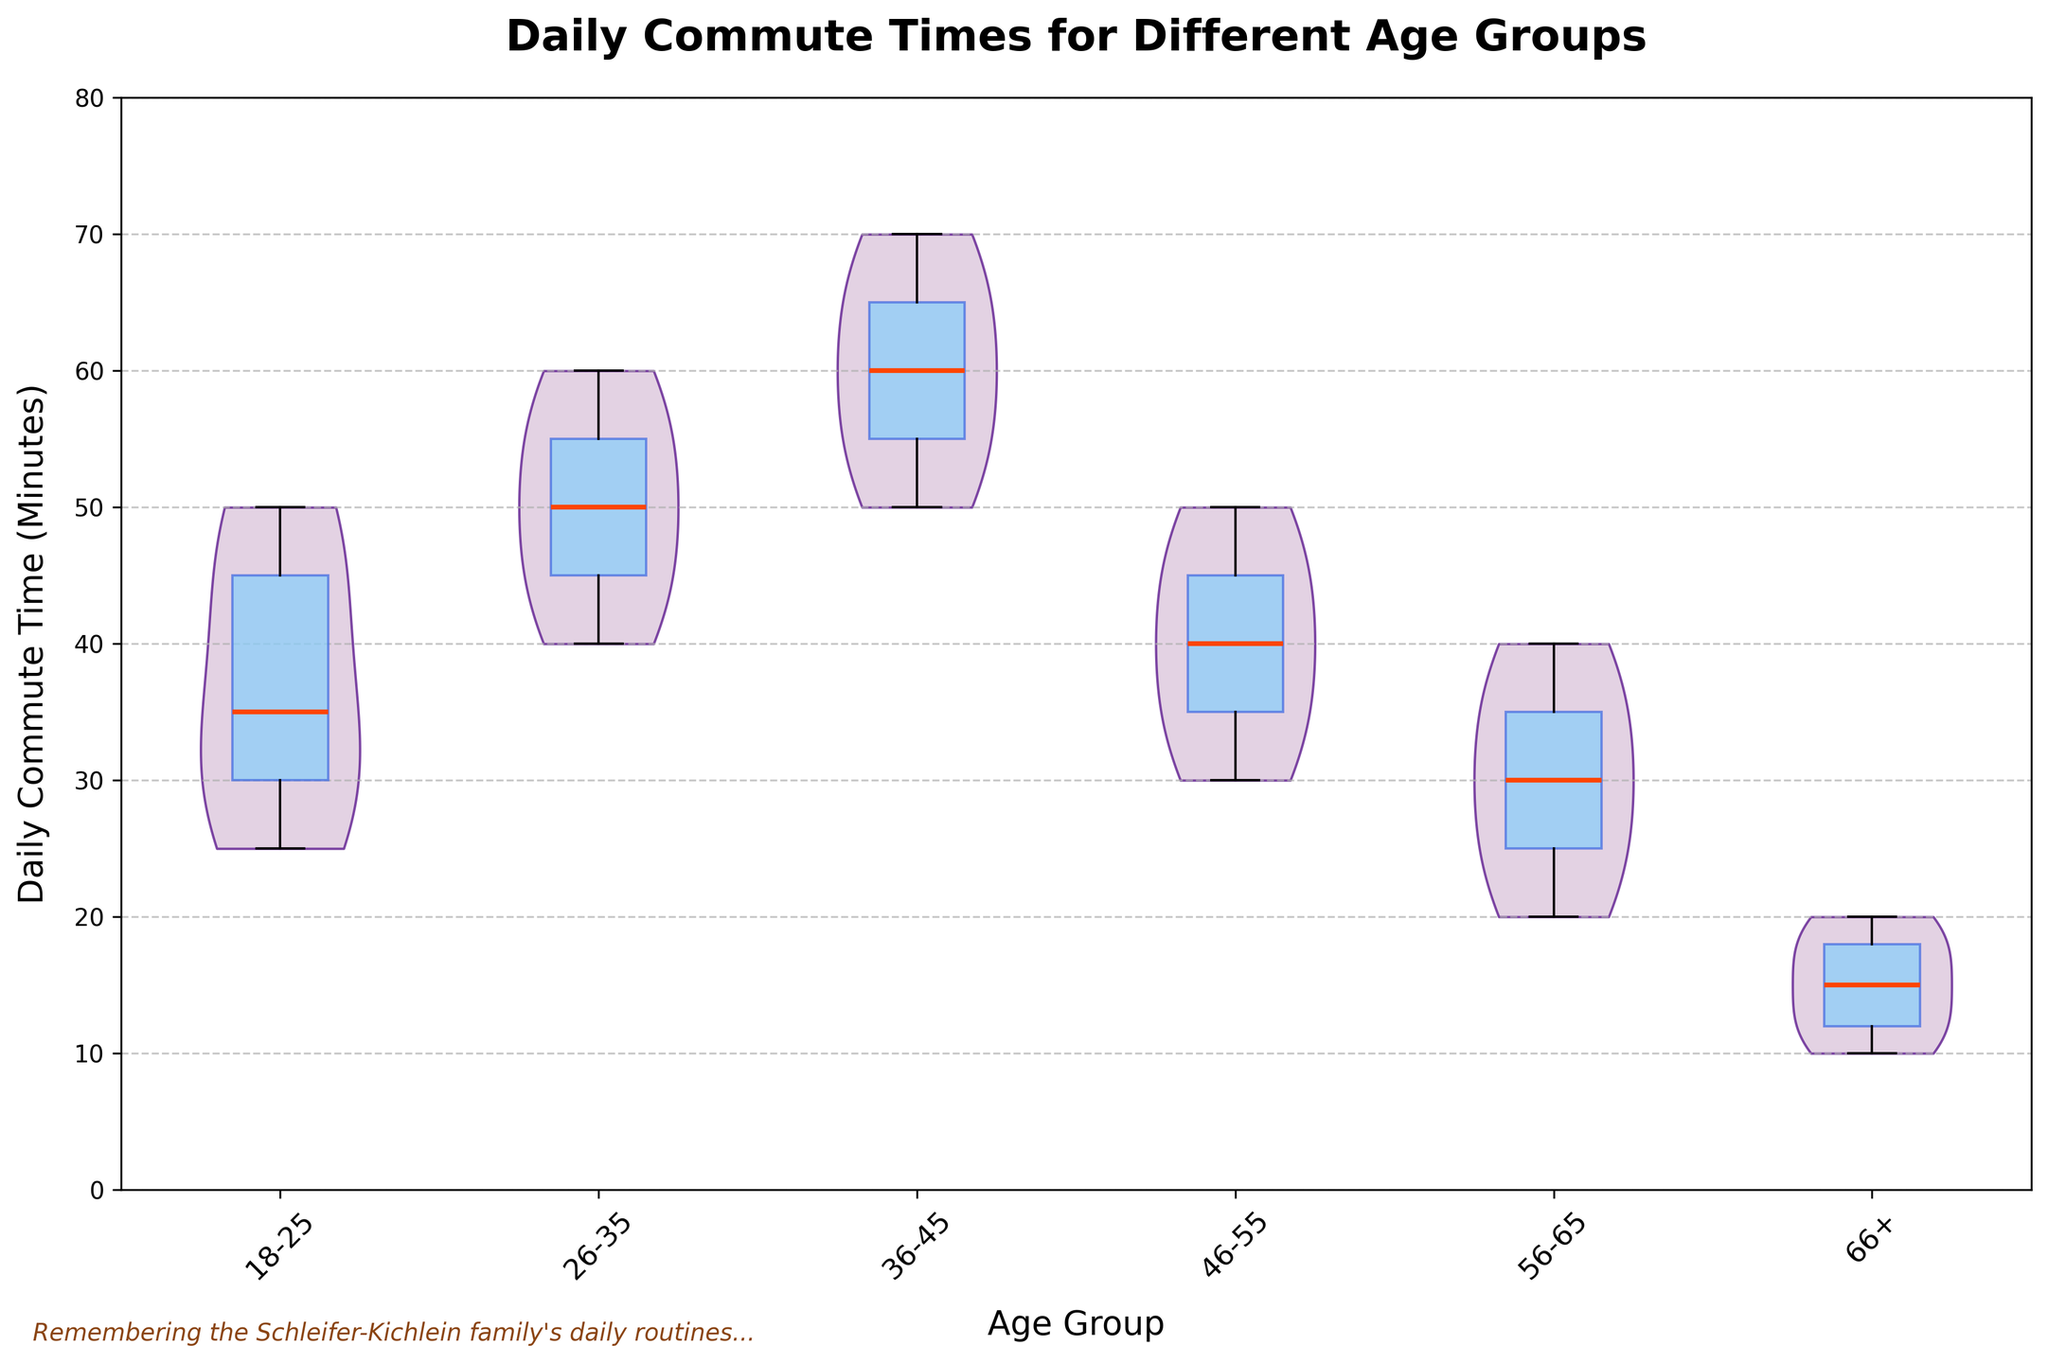What is the title of the chart? The title can be found at the top of the chart in bold font. It reads "Daily Commute Times for Different Age Groups".
Answer: Daily Commute Times for Different Age Groups What does the y-axis represent? The y-axis is labeled "Daily Commute Time (Minutes)", which indicates that it represents the time spent commuting daily, measured in minutes.
Answer: Daily Commute Time (Minutes) Which age group has the widest range of commute times? By observing the spread of the violin plots, the 36-45 age group has the widest range as its shape spans from around 50 to 70 minutes.
Answer: 36-45 What is the median commute time for the 56-65 age group? In the box plot overlay, the median is indicated by the dark line inside the box. For the 56-65 age group, the median line is at 30 minutes.
Answer: 30 minutes Which age group has the shortest average commute time? By observing the height of the violins and the position of the boxplots, the 66+ age group has the shortest average commute time, appearing at a lower position compared to other groups.
Answer: 66+ Compare the median commute times between the 26-35 and 36-45 age groups. Which is greater and by how much? The median line inside the box for the 26-35 age group is at 50, and for the 36-45 age group, it is at 60. Thus, the 36-45 group's median is greater by 10 minutes.
Answer: 36-45 by 10 minutes How are the data points distributed within the 18-25 age group? The 18-25 age group's violin plot shows a relatively even distribution with commute times ranging from approximately 25 to 50 minutes. The box plot indicates the interquartile range, with the whiskers showing min and max values.
Answer: Evenly distributed from 25 to 50 minutes Which age group shows the least variability in commute times? Observing the violin plot width, the 66+ age group has the narrowest spread, indicating the least variability in daily commute times.
Answer: 66+ Are outliers shown in this chart? The box plot overlay does not show outliers because the whiskers do not extend beyond the typical range of commute times plotted within the violins, and no separate points indicate outliers.
Answer: No 